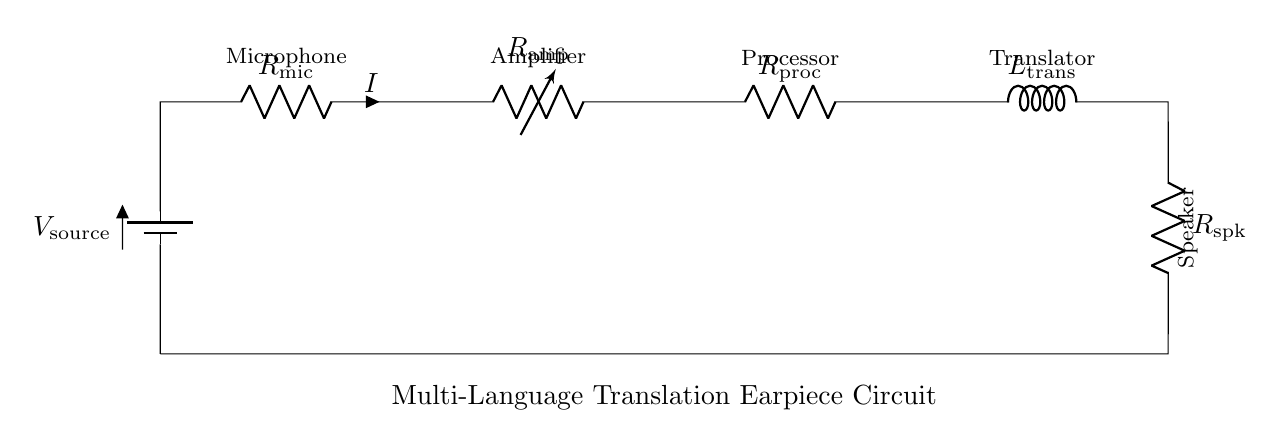What is the type of circuit depicted? The circuit is a series circuit, where all components are connected end-to-end in a single path for current flow.
Answer: Series circuit What component comes after the microphone? The component following the microphone is the amplifier, which is responsible for boosting the microphone's signal.
Answer: Amplifier How many resistors are present in the circuit? There are four resistors in the circuit: the microphone resistor, amplifier resistor, processor resistor, and speaker resistor.
Answer: Four What does the inductor represent in this circuit? The inductor represents the translator, which likely modifies the audio signal for translation purposes.
Answer: Translator What is the purpose of the speaker in this circuit? The speaker converts the processed electrical signals back into audible sound for the user to hear the translated language.
Answer: To convert signals to sound What is the role of the processor in the circuit? The processor is responsible for processing the incoming signals from the amplifier to translate the audio into another language.
Answer: Processing signals What happens to current as it flows through each component? The current remains the same throughout the circuit components because it is a series circuit, which follows the principle of constant current.
Answer: Current remains constant 